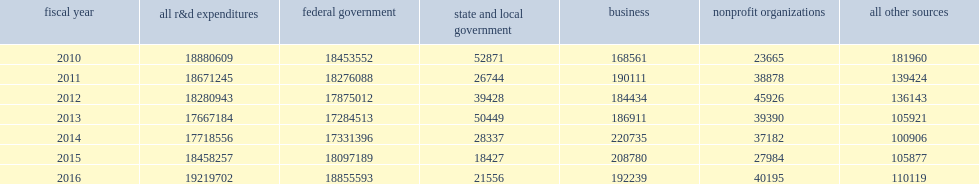How many thousand dollars did the nation's 42 federally funded research and development centers (ffrdcs) spend on r&d in fy 2016? 19219702.0. The nation's 42 federally funded research and development centers (ffrdcs) spent $19.2 billion on r&d in fy 2016, what was an annual increase of just over 4% in current dollars for the second year in a row? 0.041252. 